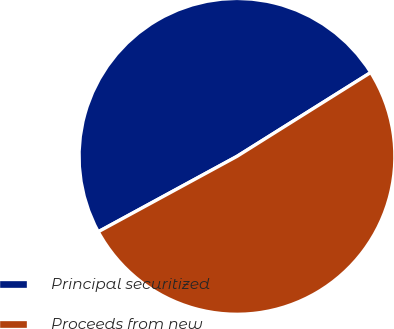Convert chart. <chart><loc_0><loc_0><loc_500><loc_500><pie_chart><fcel>Principal securitized<fcel>Proceeds from new<nl><fcel>49.01%<fcel>50.99%<nl></chart> 